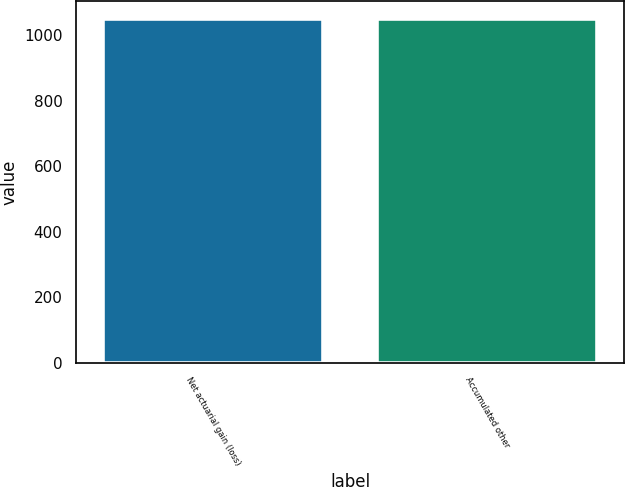Convert chart to OTSL. <chart><loc_0><loc_0><loc_500><loc_500><bar_chart><fcel>Net actuarial gain (loss)<fcel>Accumulated other<nl><fcel>1050<fcel>1050.1<nl></chart> 